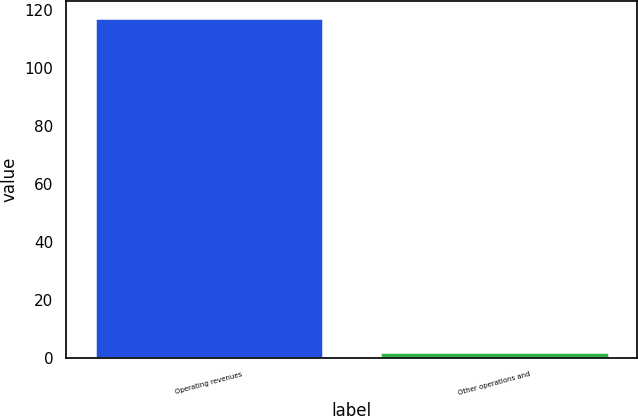Convert chart. <chart><loc_0><loc_0><loc_500><loc_500><bar_chart><fcel>Operating revenues<fcel>Other operations and<nl><fcel>117<fcel>2<nl></chart> 